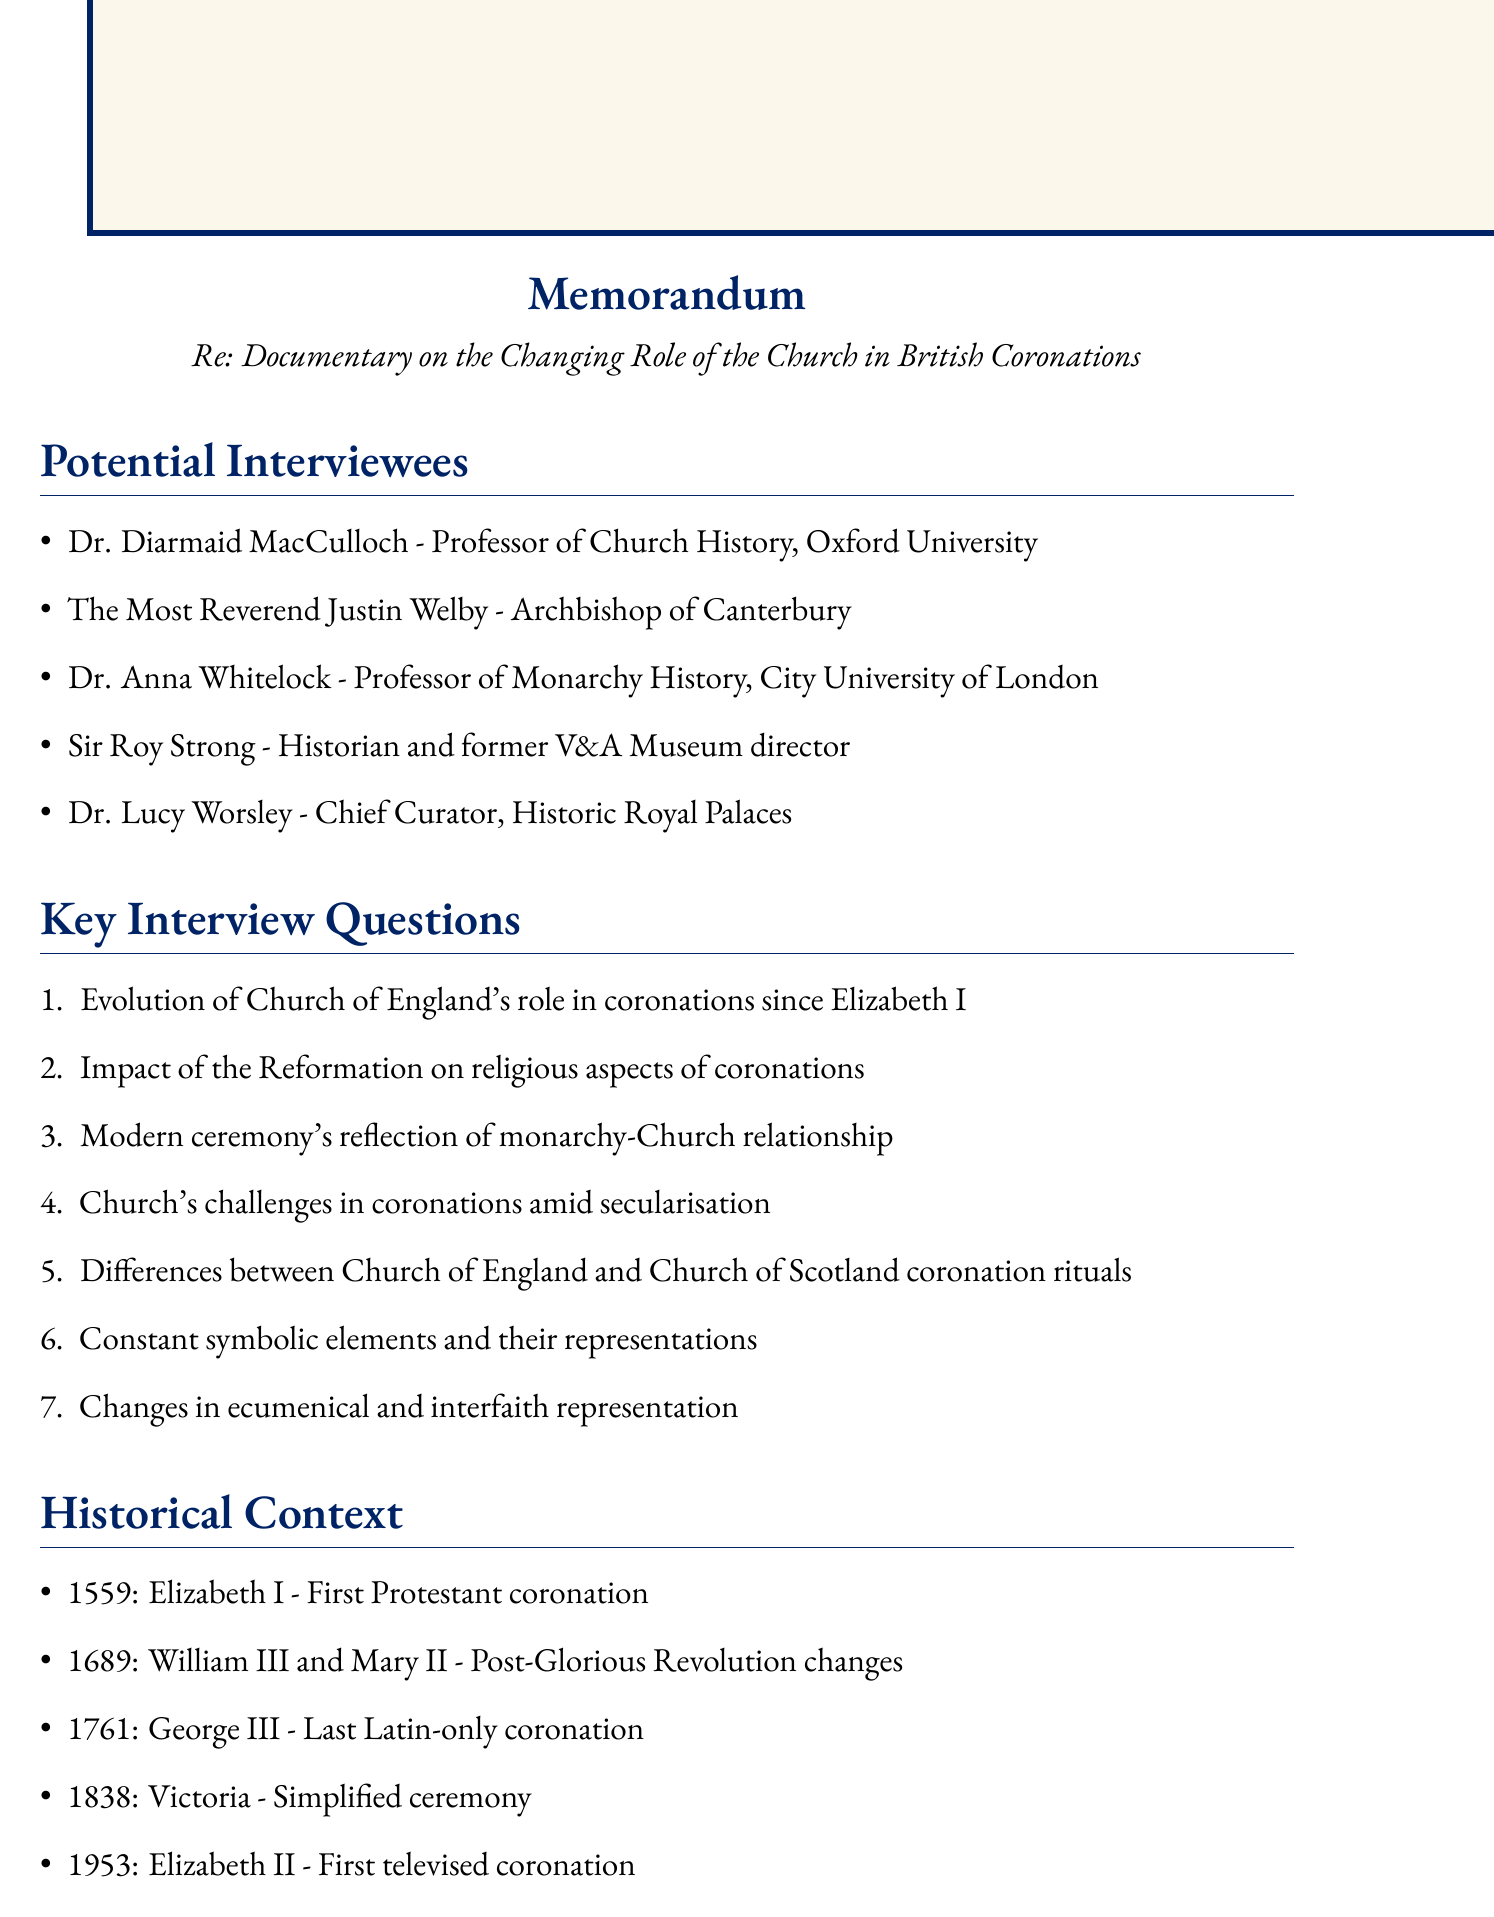What is the title of the memorandum? The title of the memorandum, as stated in the document, is about the documentary on the changing role of the Church in British coronations.
Answer: Documentary on the Changing Role of the Church in British Coronations Who is the Archbishop of Canterbury? The document lists the Archbishop of Canterbury as a potential interviewee along with his position and expertise.
Answer: The Most Reverend Justin Welby What year did Elizabeth I's coronation take place? The document provides a significant event which includes the year of Elizabeth I's coronation.
Answer: 1559 How many potential interviewees are listed? The document includes a section with potential interviewees, which can be counted.
Answer: 5 What is a key theme to explore regarding the monarchy's role? The document mentions various key themes related to the monarchy and Church, including specific themes that reflect this relationship.
Answer: The role of the monarch as Supreme Governor of the Church of England What symbolic elements are mentioned in relation to the coronation ceremony? The document references elements of the coronation ceremony and their meanings, specifically indicating a focus on continuity and tradition.
Answer: Constant symbolic elements What was significant about the coronation of Elizabeth II in 1953? The document mentions the significance of Queen Elizabeth II's coronation in historical context, specifically regarding its format.
Answer: First televised coronation What challenge does the Church face in modern society? The document mentions contemporary challenges concerning the Church's role, identifying societal trends impacting this role.
Answer: Maintaining its role in coronations in an increasingly secular society 